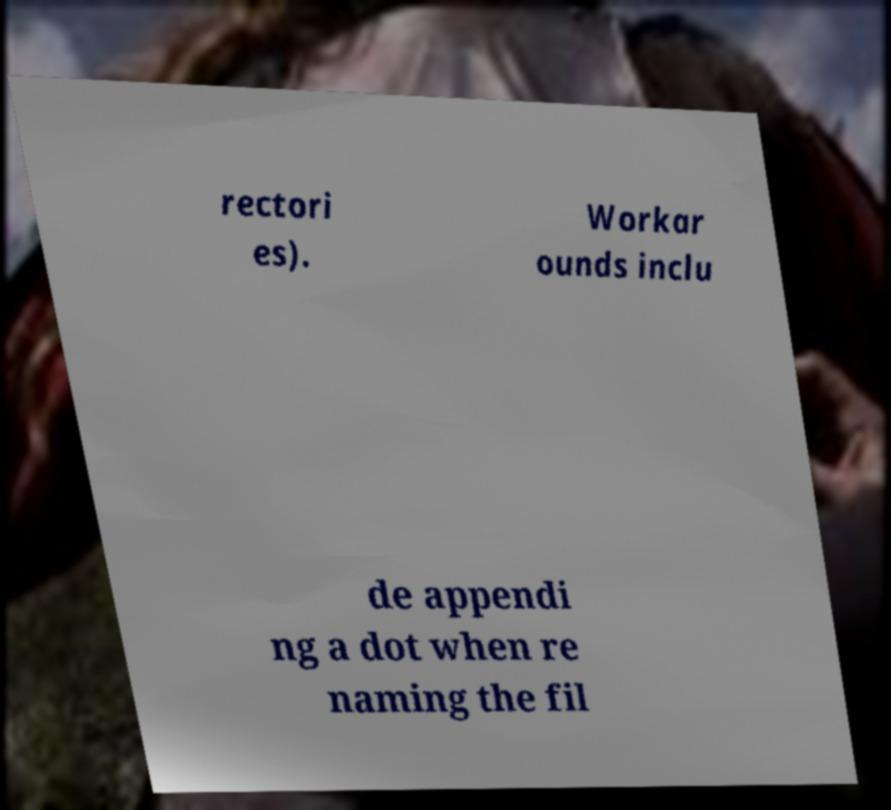Could you extract and type out the text from this image? rectori es). Workar ounds inclu de appendi ng a dot when re naming the fil 